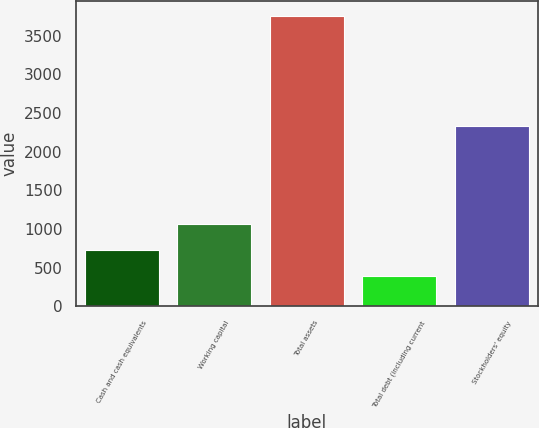Convert chart. <chart><loc_0><loc_0><loc_500><loc_500><bar_chart><fcel>Cash and cash equivalents<fcel>Working capital<fcel>Total assets<fcel>Total debt (including current<fcel>Stockholders' equity<nl><fcel>734.72<fcel>1070.64<fcel>3758<fcel>398.8<fcel>2334.9<nl></chart> 